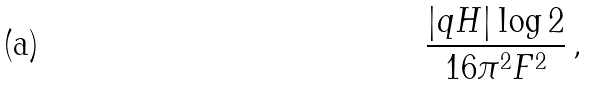<formula> <loc_0><loc_0><loc_500><loc_500>\frac { | q H | \log 2 } { 1 6 \pi ^ { 2 } F ^ { 2 } } \, ,</formula> 